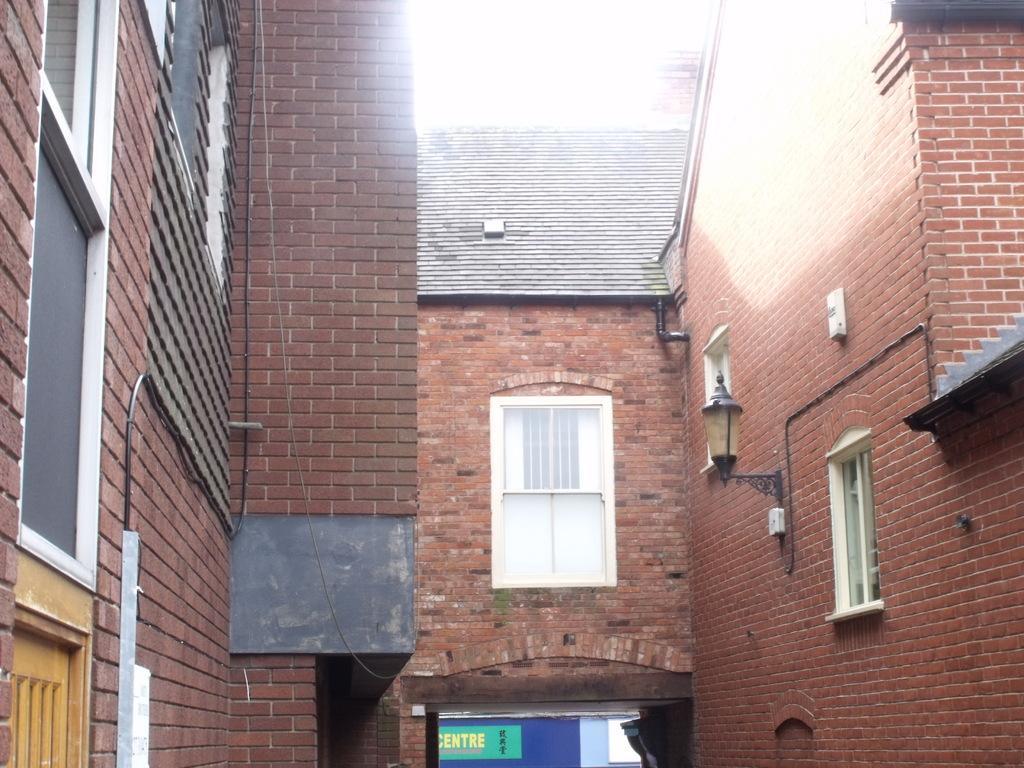Could you give a brief overview of what you see in this image? In this image, on the right side, we can see a brick wall, glass window, light. On the right side, we can also see an electric pipe. In the middle of the image, we can see a window, brick wall. On the left side, we can see a window, brick wall. At the top, we can see white color, at the bottom, we can see a hoarding with some text written on it and a white color board. 